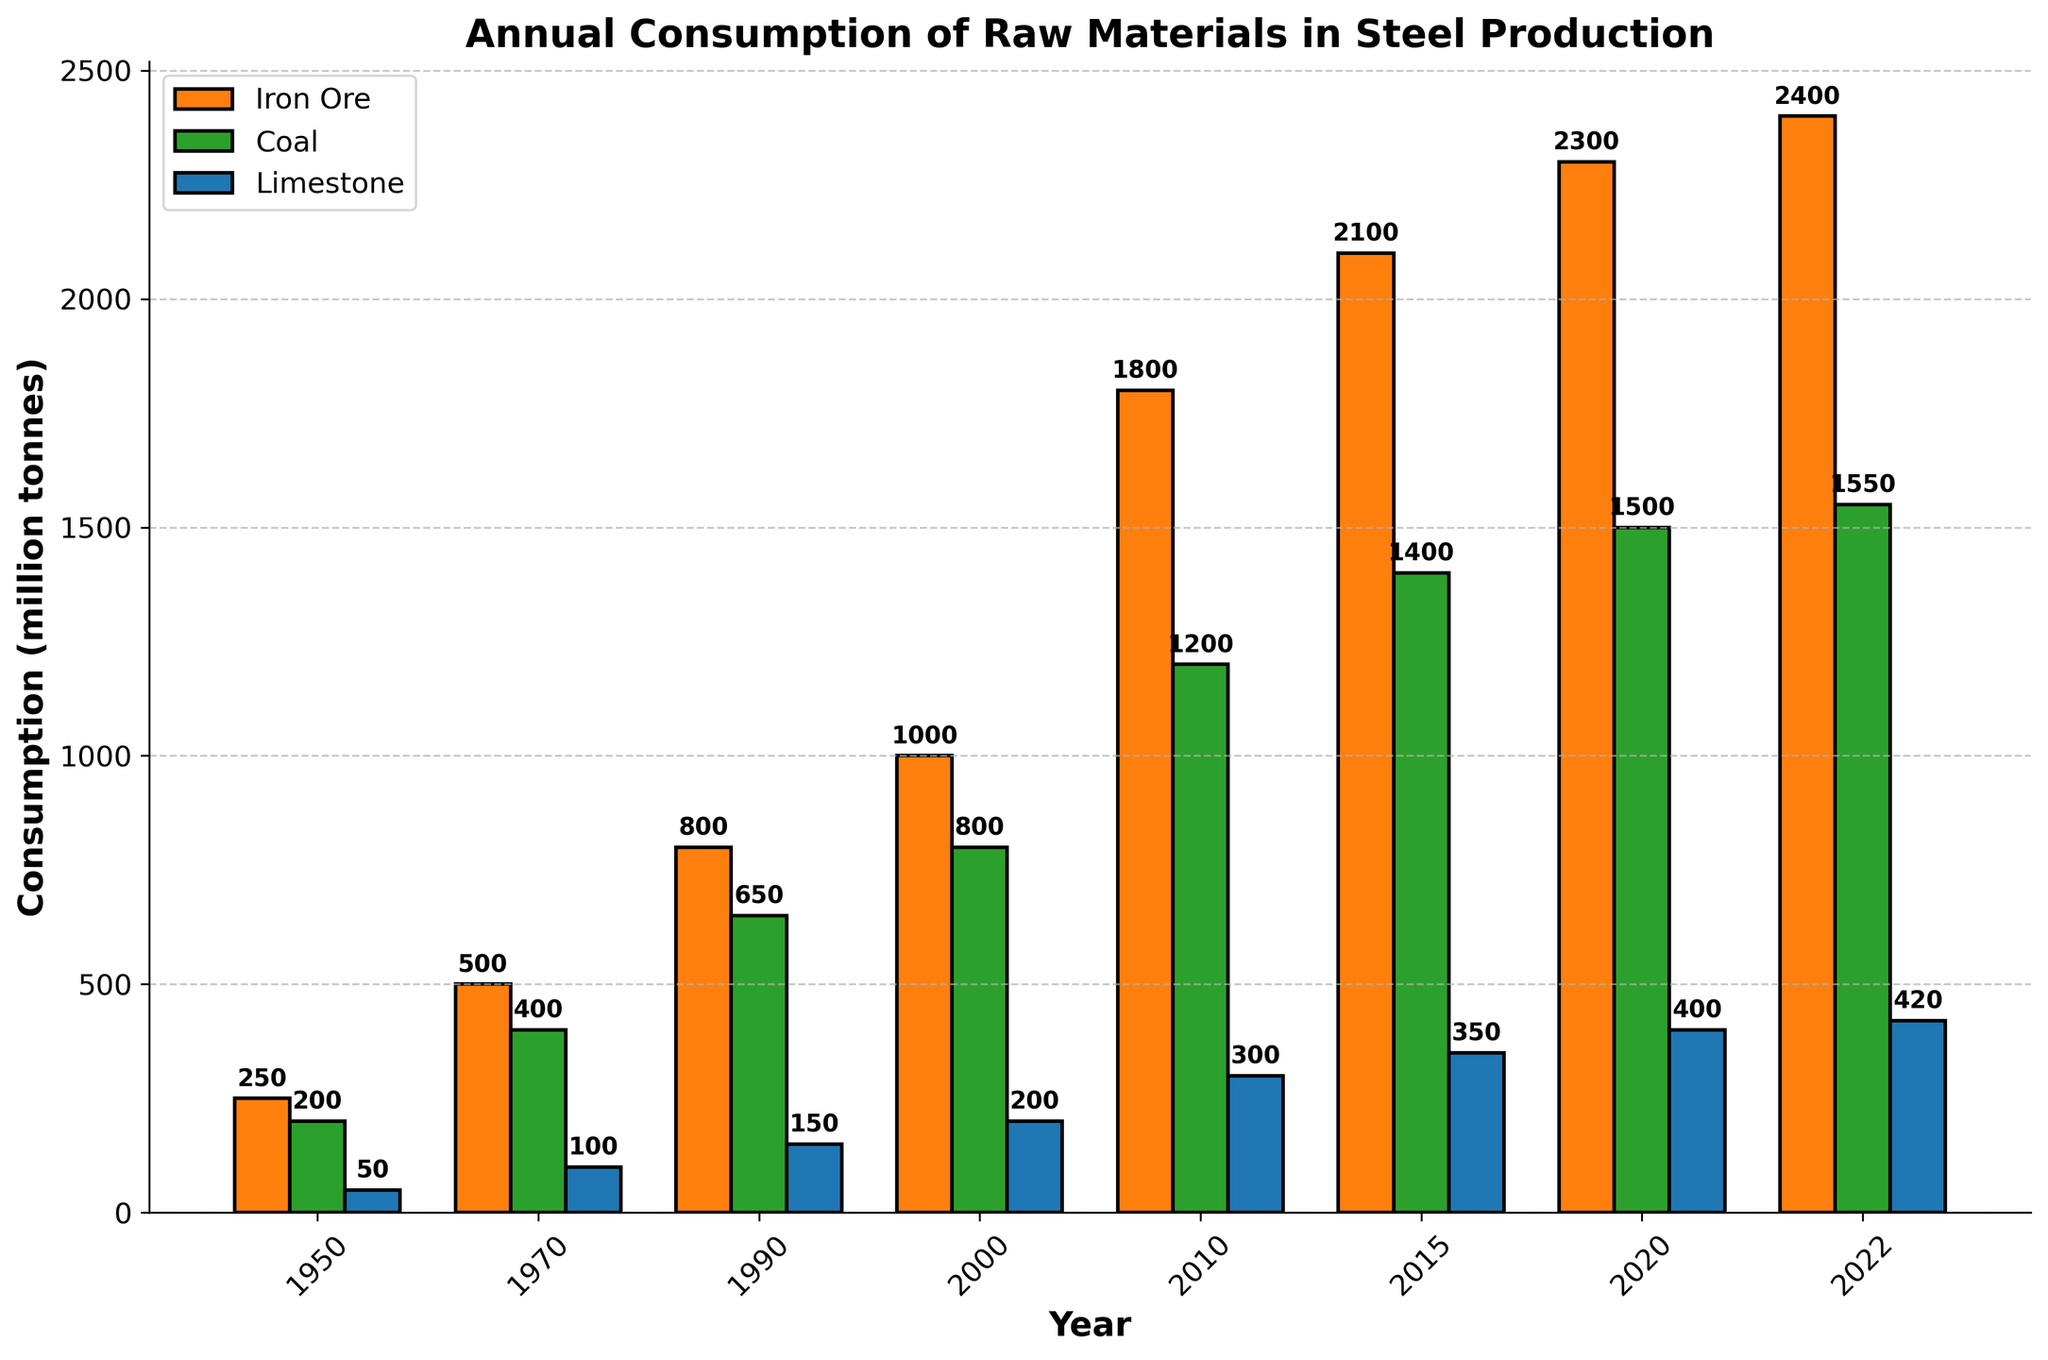What was the consumption of limestone in 2022? Look for the bar representing limestone for the year 2022 on the far right of the chart. The height of the bar indicates the value of 420 million tonnes.
Answer: 420 million tonnes In which year did coal consumption first exceed 1000 million tonnes? Examine the bars for coal and find the first year where the bar exceeds 1000 million tonnes. This occurs in 2010, where the bar height indicates 1200 million tonnes.
Answer: 2010 What is the difference in iron ore consumption between 2000 and 2022? Find the iron ore consumption for these two years from their respective bars: 1000 million tonnes in 2000 and 2400 million tonnes in 2022. Then calculate the difference: 2400 - 1000 = 1400 million tonnes.
Answer: 1400 million tonnes By how much did limestone consumption increase from 1990 to 2022? Compare the limestone bars for 1990 (150 million tonnes) and 2022 (420 million tonnes). Subtract the 1990 consumption from the 2022 consumption: 420 - 150 = 270 million tonnes.
Answer: 270 million tonnes What is the average consumption of coal from 2010 to 2022? Find the coal consumption values for the years 2010, 2015, 2020, and 2022: 1200, 1400, 1500, and 1550 million tonnes respectively. Sum these up: 1200 + 1400 + 1500 + 1550 = 5650. Divide by the number of years: 5650 / 4 = 1412.5 million tonnes.
Answer: 1412.5 million tonnes Which raw material had the highest consumption in 1970? Look at the bars for 1970: iron ore, coal, and limestone. Coal's bar is the highest at 400 million tonnes.
Answer: Coal How much more iron ore was consumed in 2022 compared to 1970? Note the iron ore consumption for 2022 (2400 million tonnes) and 1970 (500 million tonnes). Calculate the difference: 2400 - 500 = 1900 million tonnes.
Answer: 1900 million tonnes What is the combined consumption of iron ore, coal, and limestone in 2015? Add the bars for iron ore, coal, and limestone for 2015. Values are 2100, 1400, and 350 million tonnes respectively. The sum is 2100 + 1400 + 350 = 3850 million tonnes.
Answer: 3850 million tonnes In which year did limestone consumption reach half of the iron ore consumption? Compare limestone and iron ore consumption bars over the years. In 2000, limestone (200 million tonnes) is exactly half of iron ore (1000 million tonnes).
Answer: 2000 Which raw material showed the most consistent increase in consumption over the years? Examine the trends of the bars for each material from 1950 to 2022. Iron ore consistently increases every interval.
Answer: Iron ore 